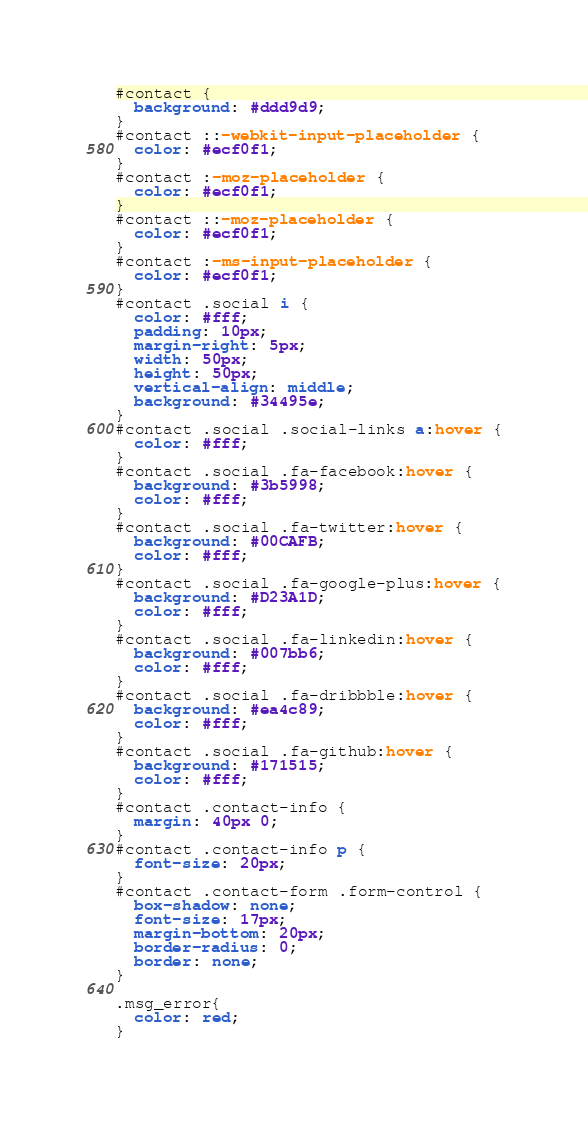Convert code to text. <code><loc_0><loc_0><loc_500><loc_500><_CSS_>#contact {
  background: #ddd9d9;
}
#contact ::-webkit-input-placeholder {
  color: #ecf0f1;
}
#contact :-moz-placeholder {
  color: #ecf0f1;
}
#contact ::-moz-placeholder {
  color: #ecf0f1;
}
#contact :-ms-input-placeholder {
  color: #ecf0f1;
}
#contact .social i {
  color: #fff;
  padding: 10px;
  margin-right: 5px;
  width: 50px;
  height: 50px;
  vertical-align: middle;
  background: #34495e;
}
#contact .social .social-links a:hover {
  color: #fff;
}
#contact .social .fa-facebook:hover {
  background: #3b5998;
  color: #fff;
}
#contact .social .fa-twitter:hover {
  background: #00CAFB;
  color: #fff;
}
#contact .social .fa-google-plus:hover {
  background: #D23A1D;
  color: #fff;
}
#contact .social .fa-linkedin:hover {
  background: #007bb6;
  color: #fff;
}
#contact .social .fa-dribbble:hover {
  background: #ea4c89;
  color: #fff;
}
#contact .social .fa-github:hover {
  background: #171515;
  color: #fff;
}
#contact .contact-info {
  margin: 40px 0;
}
#contact .contact-info p {
  font-size: 20px;
}
#contact .contact-form .form-control {
  box-shadow: none;
  font-size: 17px;
  margin-bottom: 20px;
  border-radius: 0;
  border: none;
}

.msg_error{
  color: red;
}
</code> 